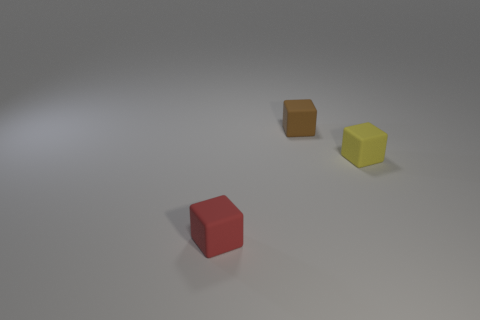How many cubes are in the image, and can you identify their colors? There are three cubes in the image. Starting from the left, the first cube is red, the second is orange, and the third is yellow. 